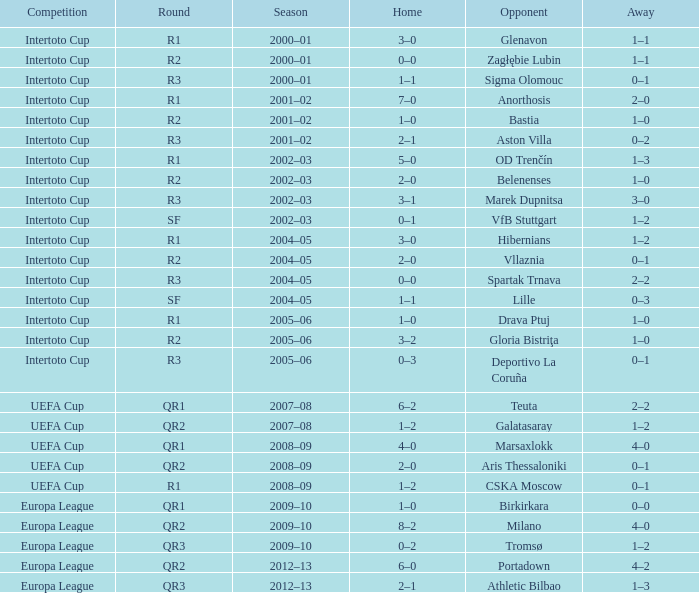What is the home score with marek dupnitsa as opponent? 3–1. 